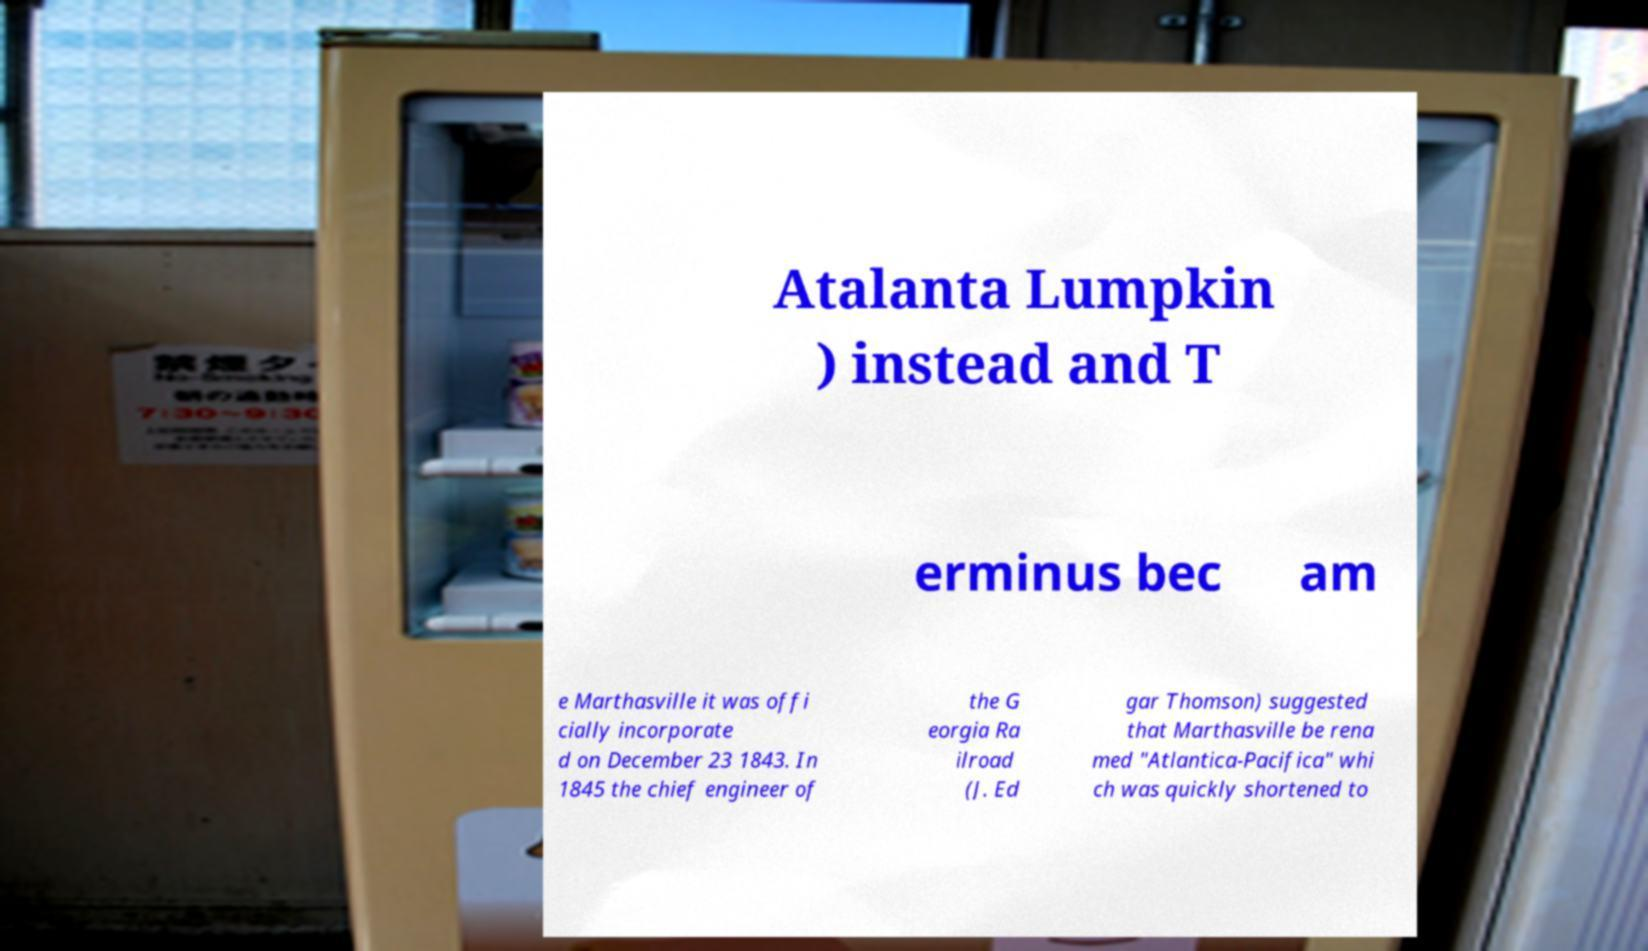Can you accurately transcribe the text from the provided image for me? Atalanta Lumpkin ) instead and T erminus bec am e Marthasville it was offi cially incorporate d on December 23 1843. In 1845 the chief engineer of the G eorgia Ra ilroad (J. Ed gar Thomson) suggested that Marthasville be rena med "Atlantica-Pacifica" whi ch was quickly shortened to 